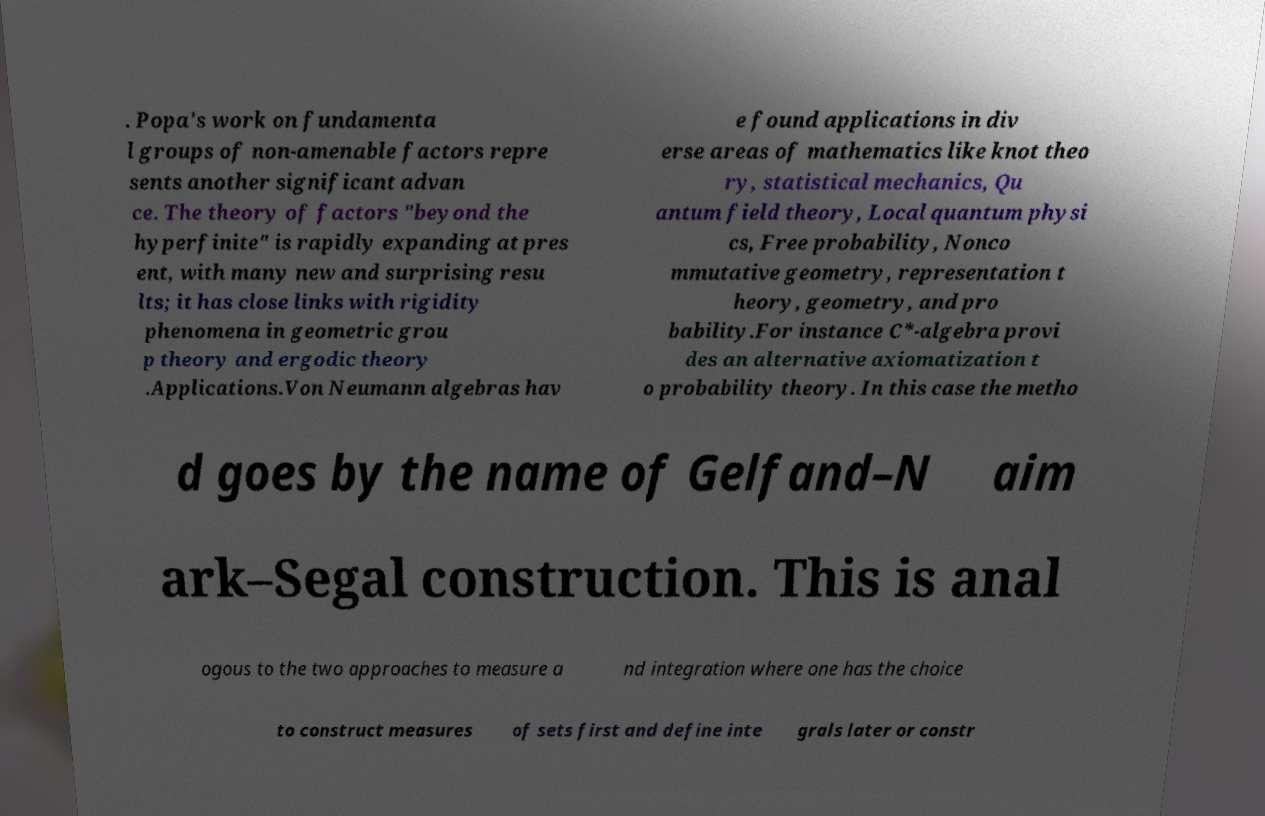Can you read and provide the text displayed in the image?This photo seems to have some interesting text. Can you extract and type it out for me? . Popa's work on fundamenta l groups of non-amenable factors repre sents another significant advan ce. The theory of factors "beyond the hyperfinite" is rapidly expanding at pres ent, with many new and surprising resu lts; it has close links with rigidity phenomena in geometric grou p theory and ergodic theory .Applications.Von Neumann algebras hav e found applications in div erse areas of mathematics like knot theo ry, statistical mechanics, Qu antum field theory, Local quantum physi cs, Free probability, Nonco mmutative geometry, representation t heory, geometry, and pro bability.For instance C*-algebra provi des an alternative axiomatization t o probability theory. In this case the metho d goes by the name of Gelfand–N aim ark–Segal construction. This is anal ogous to the two approaches to measure a nd integration where one has the choice to construct measures of sets first and define inte grals later or constr 